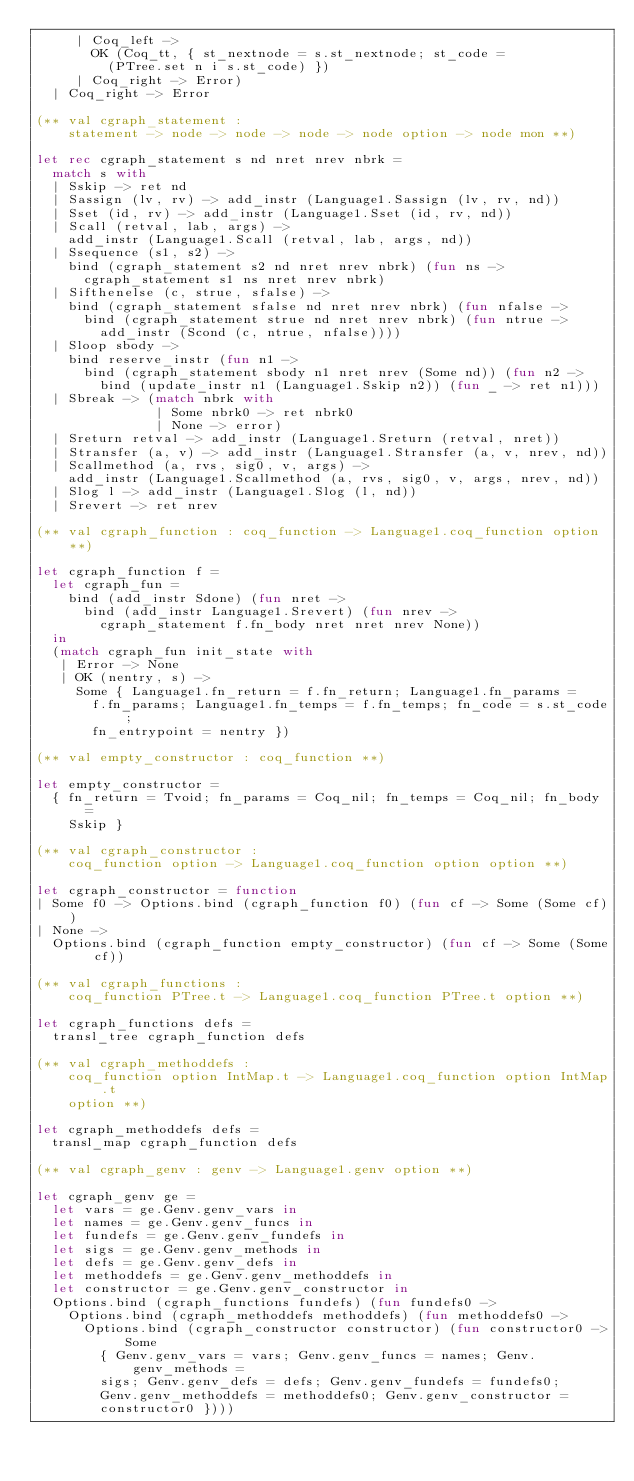Convert code to text. <code><loc_0><loc_0><loc_500><loc_500><_OCaml_>     | Coq_left ->
       OK (Coq_tt, { st_nextnode = s.st_nextnode; st_code =
         (PTree.set n i s.st_code) })
     | Coq_right -> Error)
  | Coq_right -> Error

(** val cgraph_statement :
    statement -> node -> node -> node -> node option -> node mon **)

let rec cgraph_statement s nd nret nrev nbrk =
  match s with
  | Sskip -> ret nd
  | Sassign (lv, rv) -> add_instr (Language1.Sassign (lv, rv, nd))
  | Sset (id, rv) -> add_instr (Language1.Sset (id, rv, nd))
  | Scall (retval, lab, args) ->
    add_instr (Language1.Scall (retval, lab, args, nd))
  | Ssequence (s1, s2) ->
    bind (cgraph_statement s2 nd nret nrev nbrk) (fun ns ->
      cgraph_statement s1 ns nret nrev nbrk)
  | Sifthenelse (c, strue, sfalse) ->
    bind (cgraph_statement sfalse nd nret nrev nbrk) (fun nfalse ->
      bind (cgraph_statement strue nd nret nrev nbrk) (fun ntrue ->
        add_instr (Scond (c, ntrue, nfalse))))
  | Sloop sbody ->
    bind reserve_instr (fun n1 ->
      bind (cgraph_statement sbody n1 nret nrev (Some nd)) (fun n2 ->
        bind (update_instr n1 (Language1.Sskip n2)) (fun _ -> ret n1)))
  | Sbreak -> (match nbrk with
               | Some nbrk0 -> ret nbrk0
               | None -> error)
  | Sreturn retval -> add_instr (Language1.Sreturn (retval, nret))
  | Stransfer (a, v) -> add_instr (Language1.Stransfer (a, v, nrev, nd))
  | Scallmethod (a, rvs, sig0, v, args) ->
    add_instr (Language1.Scallmethod (a, rvs, sig0, v, args, nrev, nd))
  | Slog l -> add_instr (Language1.Slog (l, nd))
  | Srevert -> ret nrev

(** val cgraph_function : coq_function -> Language1.coq_function option **)

let cgraph_function f =
  let cgraph_fun =
    bind (add_instr Sdone) (fun nret ->
      bind (add_instr Language1.Srevert) (fun nrev ->
        cgraph_statement f.fn_body nret nret nrev None))
  in
  (match cgraph_fun init_state with
   | Error -> None
   | OK (nentry, s) ->
     Some { Language1.fn_return = f.fn_return; Language1.fn_params =
       f.fn_params; Language1.fn_temps = f.fn_temps; fn_code = s.st_code;
       fn_entrypoint = nentry })

(** val empty_constructor : coq_function **)

let empty_constructor =
  { fn_return = Tvoid; fn_params = Coq_nil; fn_temps = Coq_nil; fn_body =
    Sskip }

(** val cgraph_constructor :
    coq_function option -> Language1.coq_function option option **)

let cgraph_constructor = function
| Some f0 -> Options.bind (cgraph_function f0) (fun cf -> Some (Some cf))
| None ->
  Options.bind (cgraph_function empty_constructor) (fun cf -> Some (Some cf))

(** val cgraph_functions :
    coq_function PTree.t -> Language1.coq_function PTree.t option **)

let cgraph_functions defs =
  transl_tree cgraph_function defs

(** val cgraph_methoddefs :
    coq_function option IntMap.t -> Language1.coq_function option IntMap.t
    option **)

let cgraph_methoddefs defs =
  transl_map cgraph_function defs

(** val cgraph_genv : genv -> Language1.genv option **)

let cgraph_genv ge =
  let vars = ge.Genv.genv_vars in
  let names = ge.Genv.genv_funcs in
  let fundefs = ge.Genv.genv_fundefs in
  let sigs = ge.Genv.genv_methods in
  let defs = ge.Genv.genv_defs in
  let methoddefs = ge.Genv.genv_methoddefs in
  let constructor = ge.Genv.genv_constructor in
  Options.bind (cgraph_functions fundefs) (fun fundefs0 ->
    Options.bind (cgraph_methoddefs methoddefs) (fun methoddefs0 ->
      Options.bind (cgraph_constructor constructor) (fun constructor0 -> Some
        { Genv.genv_vars = vars; Genv.genv_funcs = names; Genv.genv_methods =
        sigs; Genv.genv_defs = defs; Genv.genv_fundefs = fundefs0;
        Genv.genv_methoddefs = methoddefs0; Genv.genv_constructor =
        constructor0 })))
</code> 